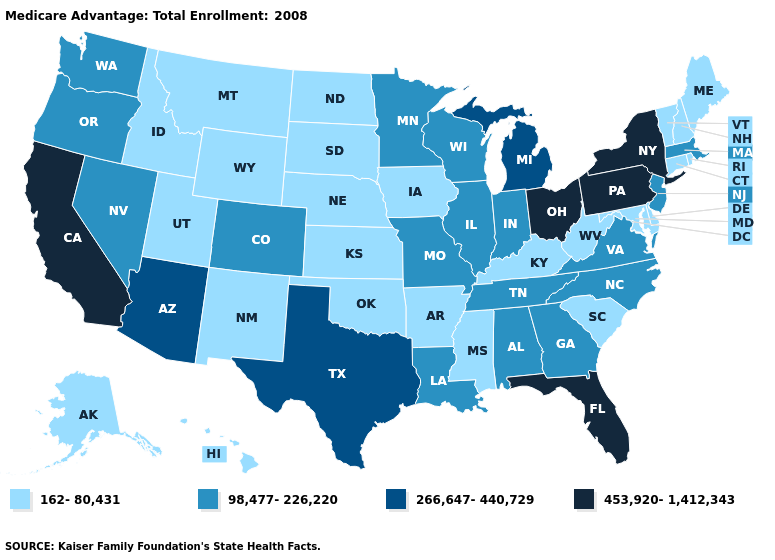Among the states that border Connecticut , does New York have the lowest value?
Be succinct. No. Name the states that have a value in the range 453,920-1,412,343?
Concise answer only. California, Florida, New York, Ohio, Pennsylvania. Which states have the lowest value in the USA?
Quick response, please. Alaska, Arkansas, Connecticut, Delaware, Hawaii, Iowa, Idaho, Kansas, Kentucky, Maryland, Maine, Mississippi, Montana, North Dakota, Nebraska, New Hampshire, New Mexico, Oklahoma, Rhode Island, South Carolina, South Dakota, Utah, Vermont, West Virginia, Wyoming. What is the value of Maryland?
Be succinct. 162-80,431. Name the states that have a value in the range 266,647-440,729?
Concise answer only. Arizona, Michigan, Texas. Does Connecticut have the lowest value in the USA?
Keep it brief. Yes. Which states hav the highest value in the West?
Keep it brief. California. What is the value of Alabama?
Write a very short answer. 98,477-226,220. What is the value of South Dakota?
Short answer required. 162-80,431. Does the first symbol in the legend represent the smallest category?
Write a very short answer. Yes. What is the value of Georgia?
Give a very brief answer. 98,477-226,220. What is the highest value in the USA?
Be succinct. 453,920-1,412,343. Name the states that have a value in the range 266,647-440,729?
Quick response, please. Arizona, Michigan, Texas. Name the states that have a value in the range 453,920-1,412,343?
Quick response, please. California, Florida, New York, Ohio, Pennsylvania. Does North Carolina have the lowest value in the USA?
Be succinct. No. 